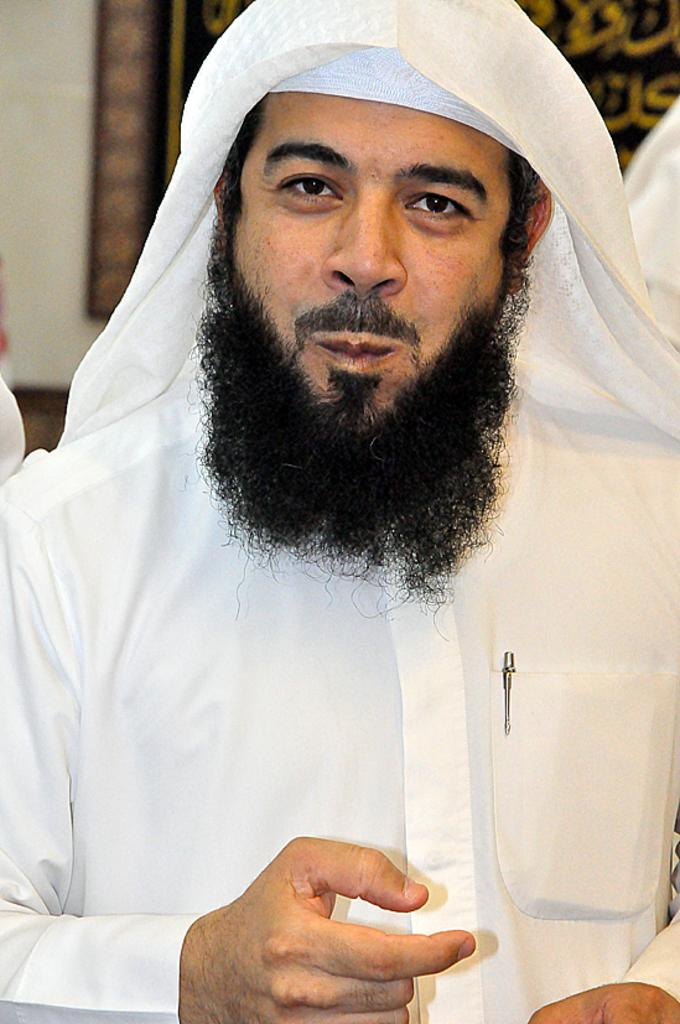Who is the main subject in the image? There is a man in the image. What is the man doing in the image? The man is standing in the front, smiling, and giving a pose to the camera. What can be seen in the background of the image? There is a black poster on the wall in the background. What type of quiver is the man holding in the image? There is no quiver present in the image. What kind of boots is the man wearing in the image? The image does not show the man's footwear, so it cannot be determined what type of boots he might be wearing. 